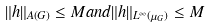Convert formula to latex. <formula><loc_0><loc_0><loc_500><loc_500>\| h \| _ { A ( G ) } \leq M a n d \| h \| _ { L ^ { \infty } ( \mu _ { G } ) } \leq M</formula> 